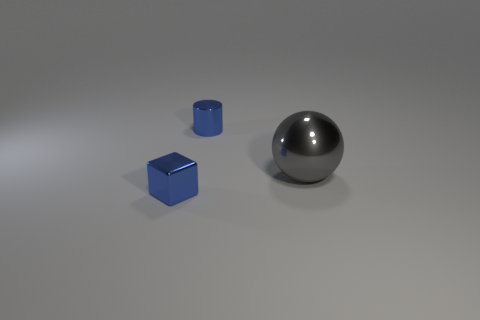There is a small thing in front of the large sphere; what is it made of?
Give a very brief answer. Metal. Is the number of large spheres that are behind the gray metal ball less than the number of yellow shiny cylinders?
Keep it short and to the point. No. Is there any other thing that has the same shape as the large object?
Offer a very short reply. No. Are there any tiny blue metallic cylinders?
Provide a short and direct response. Yes. Do the large gray object and the blue shiny object that is in front of the big sphere have the same shape?
Provide a succinct answer. No. The tiny blue object that is right of the small blue metal thing in front of the gray ball is made of what material?
Ensure brevity in your answer.  Metal. What is the color of the shiny cylinder?
Your answer should be compact. Blue. There is a metal object on the right side of the blue cylinder; does it have the same color as the object on the left side of the blue shiny cylinder?
Offer a very short reply. No. Is there a tiny thing that has the same color as the tiny cylinder?
Offer a very short reply. Yes. There is a cylinder that is the same color as the cube; what material is it?
Provide a short and direct response. Metal. 